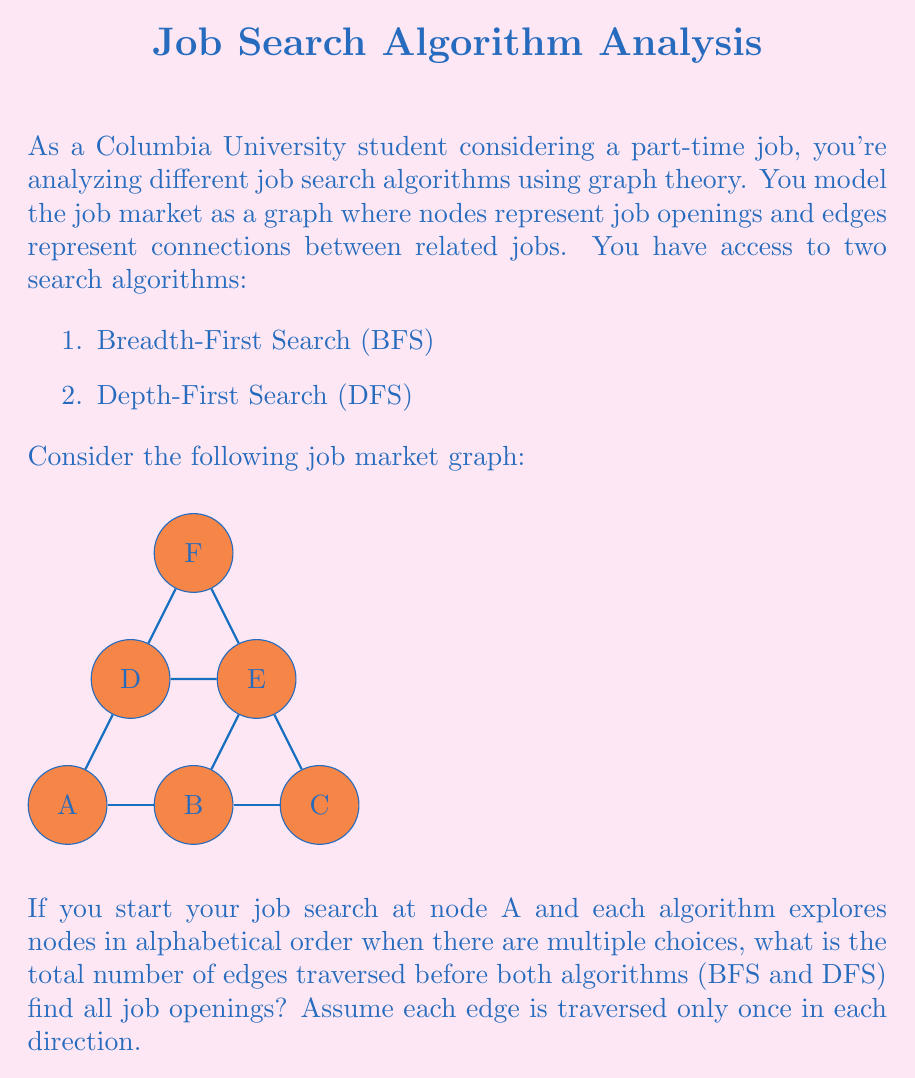Can you solve this math problem? Let's analyze this step-by-step:

1) First, let's trace the path of each algorithm:

   BFS: 
   - Start at A
   - Explore A's neighbors: B and D
   - Explore B's neighbors: C and E
   - Explore D's neighbors: E and F
   - Explore C's neighbors: (all visited)
   - Explore E's neighbors: F (already visited)
   - Explore F's neighbors: (all visited)

   DFS:
   - Start at A
   - Go to B
   - Go to C
   - Backtrack to B, go to E
   - Go to F
   - Backtrack to E, backtrack to B, backtrack to A
   - Go to D
   - Backtrack to A (all visited)

2) Now, let's count the edges traversed:

   BFS:
   - A to B, A to D (2 edges)
   - B to C, B to E, D to E, D to F (4 edges)
   - No new edges in the last steps
   Total for BFS: 6 edges

   DFS:
   - A to B, B to C (2 edges)
   - B to E, E to F (2 edges)
   - A to D (1 edge)
   Total for DFS: 5 edges

3) The question asks for the total number of edges traversed before both algorithms find all job openings. This means we need to add the edges traversed by BFS and DFS:

   Total edges = BFS edges + DFS edges = 6 + 5 = 11

Therefore, the total number of edges traversed is 11.
Answer: 11 edges 